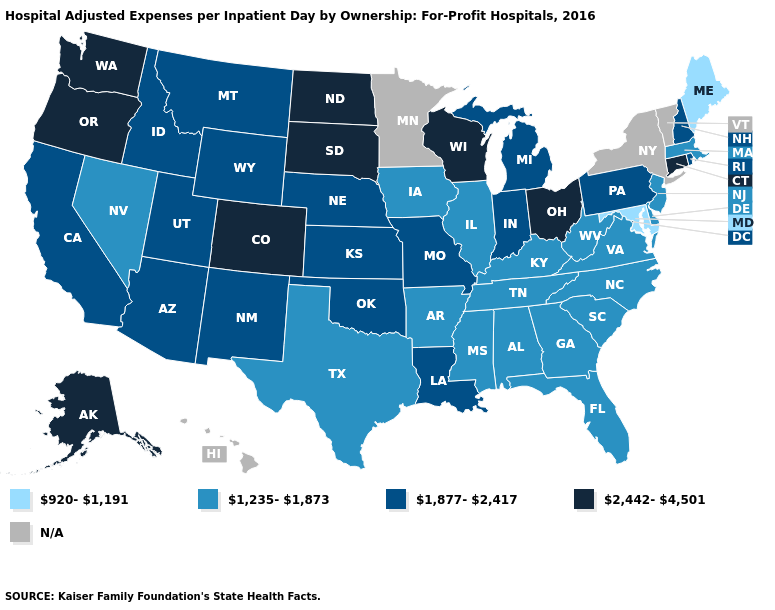What is the value of Virginia?
Answer briefly. 1,235-1,873. Name the states that have a value in the range 920-1,191?
Quick response, please. Maine, Maryland. What is the value of Illinois?
Short answer required. 1,235-1,873. What is the highest value in the USA?
Keep it brief. 2,442-4,501. Name the states that have a value in the range N/A?
Quick response, please. Hawaii, Minnesota, New York, Vermont. Among the states that border Oregon , does Nevada have the lowest value?
Short answer required. Yes. Which states hav the highest value in the West?
Answer briefly. Alaska, Colorado, Oregon, Washington. What is the value of Maine?
Write a very short answer. 920-1,191. Name the states that have a value in the range 920-1,191?
Keep it brief. Maine, Maryland. What is the lowest value in the Northeast?
Give a very brief answer. 920-1,191. Name the states that have a value in the range 920-1,191?
Write a very short answer. Maine, Maryland. What is the lowest value in the West?
Answer briefly. 1,235-1,873. What is the lowest value in the USA?
Answer briefly. 920-1,191. 